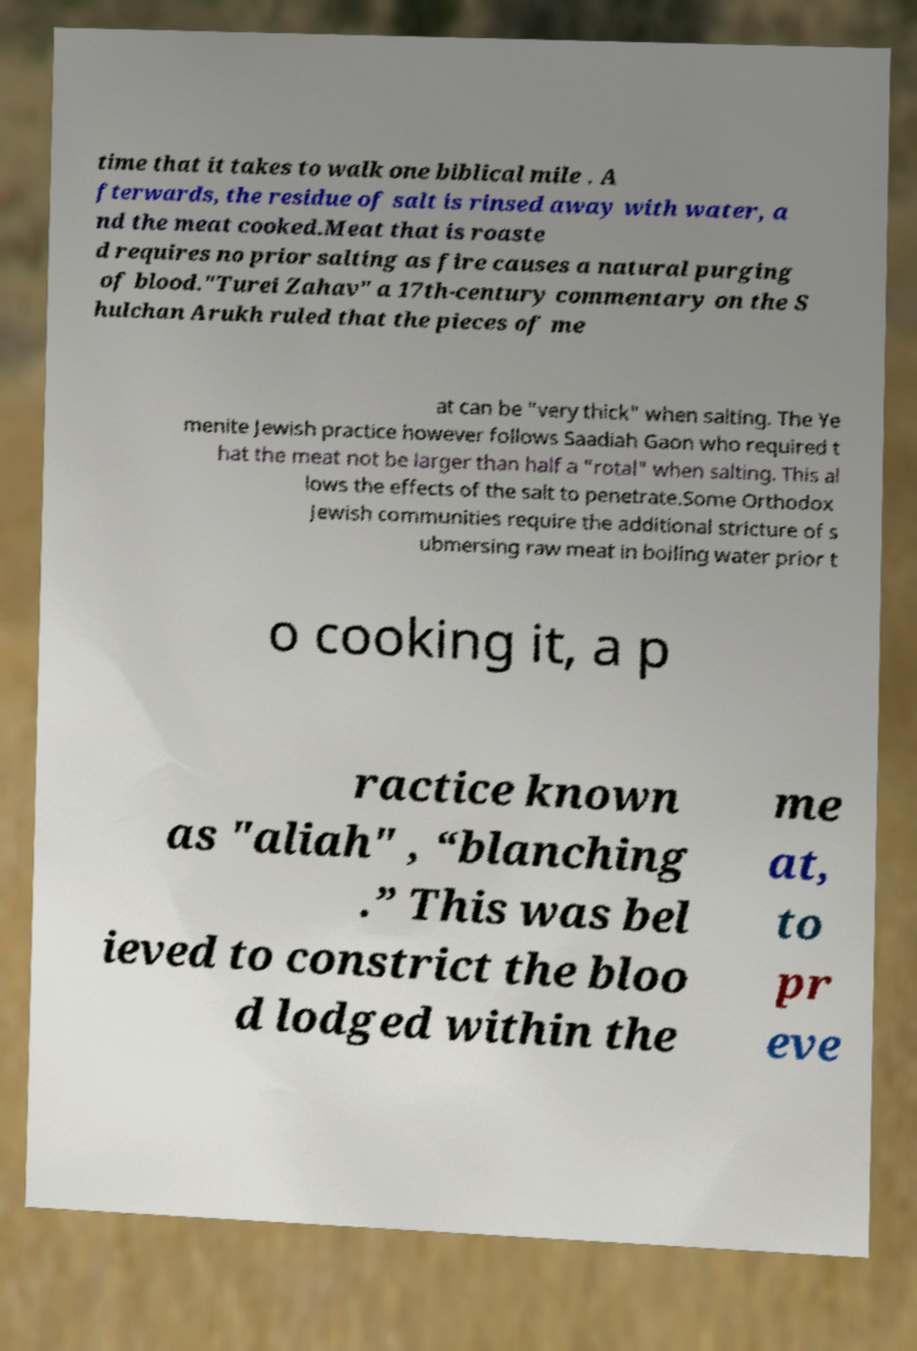Could you extract and type out the text from this image? time that it takes to walk one biblical mile . A fterwards, the residue of salt is rinsed away with water, a nd the meat cooked.Meat that is roaste d requires no prior salting as fire causes a natural purging of blood."Turei Zahav" a 17th-century commentary on the S hulchan Arukh ruled that the pieces of me at can be "very thick" when salting. The Ye menite Jewish practice however follows Saadiah Gaon who required t hat the meat not be larger than half a "rotal" when salting. This al lows the effects of the salt to penetrate.Some Orthodox Jewish communities require the additional stricture of s ubmersing raw meat in boiling water prior t o cooking it, a p ractice known as "aliah" , “blanching .” This was bel ieved to constrict the bloo d lodged within the me at, to pr eve 